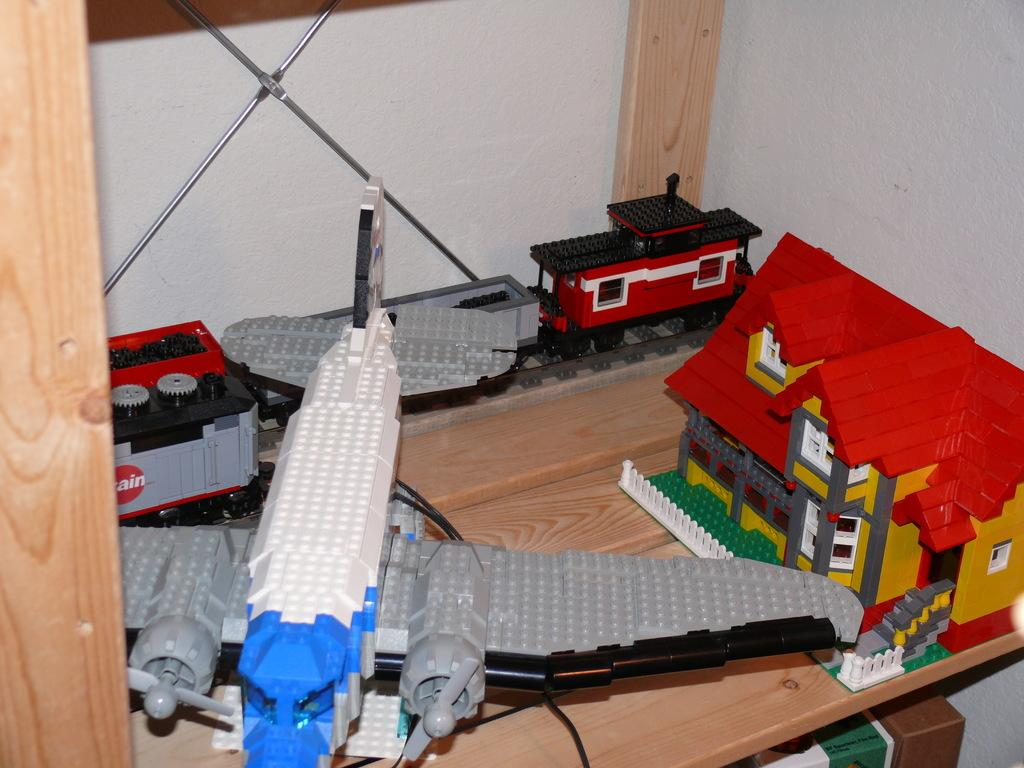What type of toys are featured in the image? There are LEGO puzzle toys in the image. Can you describe the different structures made with the LEGO puzzles? There is a train, an airplane, and a house made with LEGO puzzles. What is the surface on which the LEGO puzzles are placed? The image appears to be on a wooden table. What can be seen in the background of the image? There is a wall visible in the image. What color is the pail used to collect water in the image? There is no pail present in the image; it features LEGO puzzle toys and structures. 